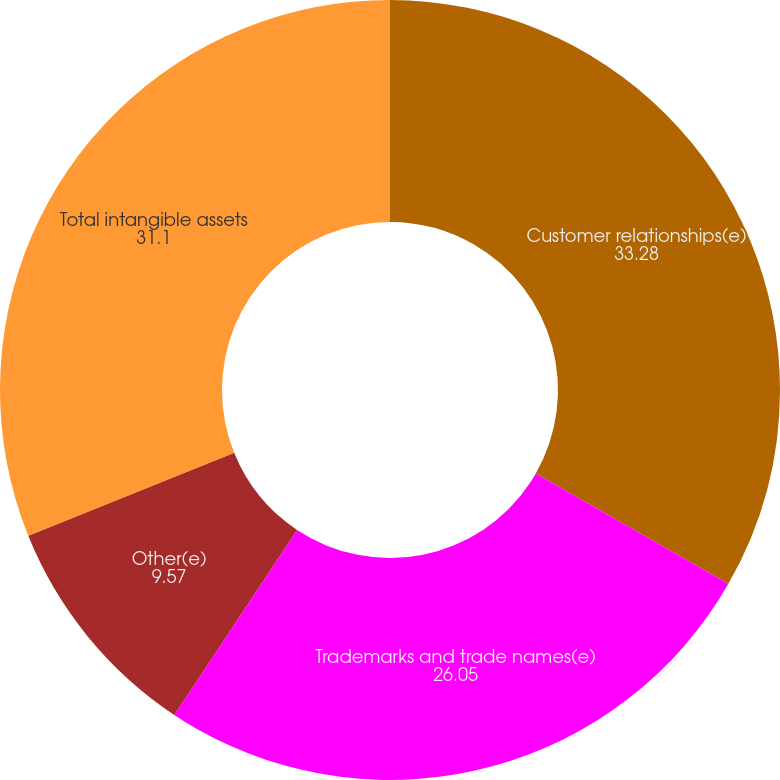Convert chart to OTSL. <chart><loc_0><loc_0><loc_500><loc_500><pie_chart><fcel>Customer relationships(e)<fcel>Trademarks and trade names(e)<fcel>Other(e)<fcel>Total intangible assets<nl><fcel>33.28%<fcel>26.05%<fcel>9.57%<fcel>31.1%<nl></chart> 